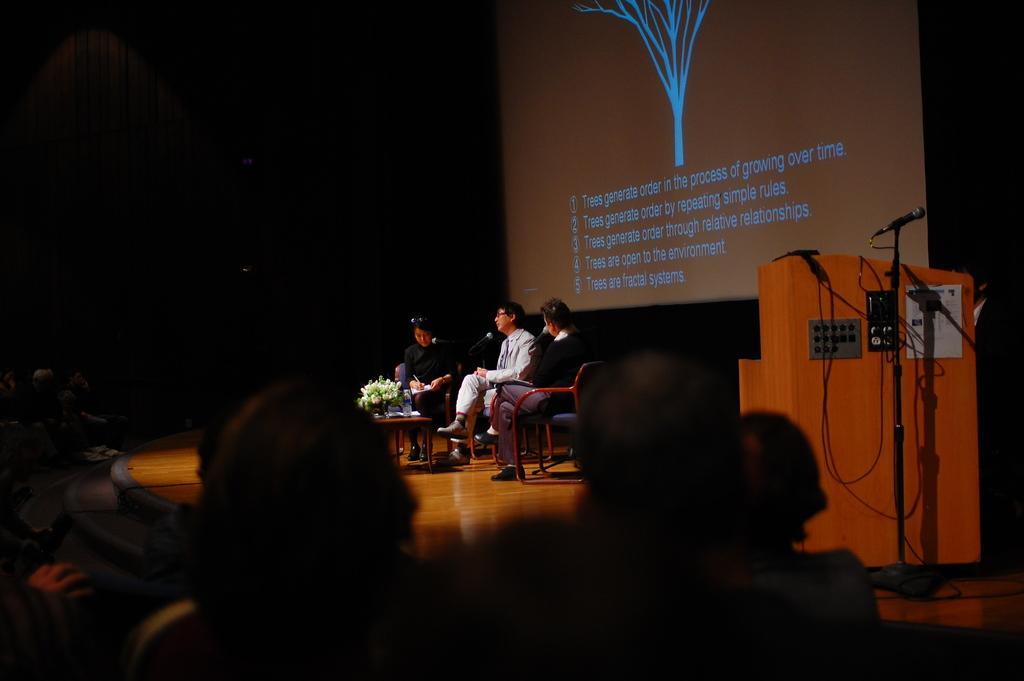Could you give a brief overview of what you see in this image? In this picture I can see few people are sitting on the stage and taking, behind there is a screen on the board, in front I can see few people. 